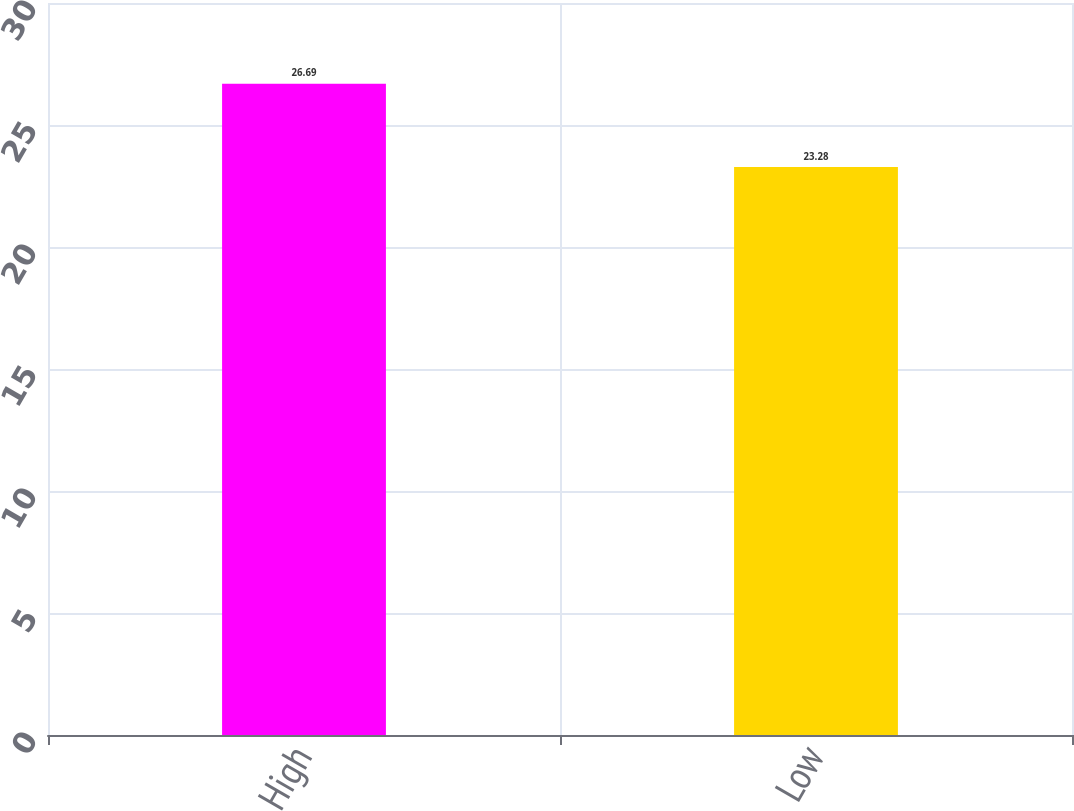<chart> <loc_0><loc_0><loc_500><loc_500><bar_chart><fcel>High<fcel>Low<nl><fcel>26.69<fcel>23.28<nl></chart> 